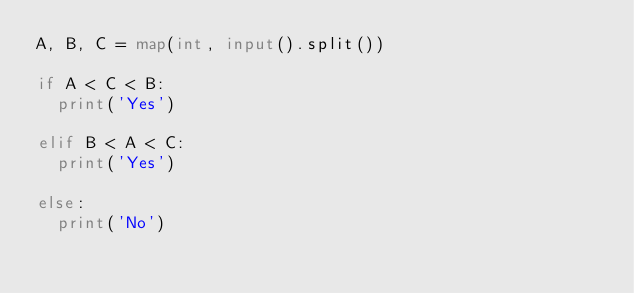Convert code to text. <code><loc_0><loc_0><loc_500><loc_500><_Python_>A, B, C = map(int, input().split())

if A < C < B:
  print('Yes')
  
elif B < A < C:
  print('Yes')
  
else:
  print('No')</code> 